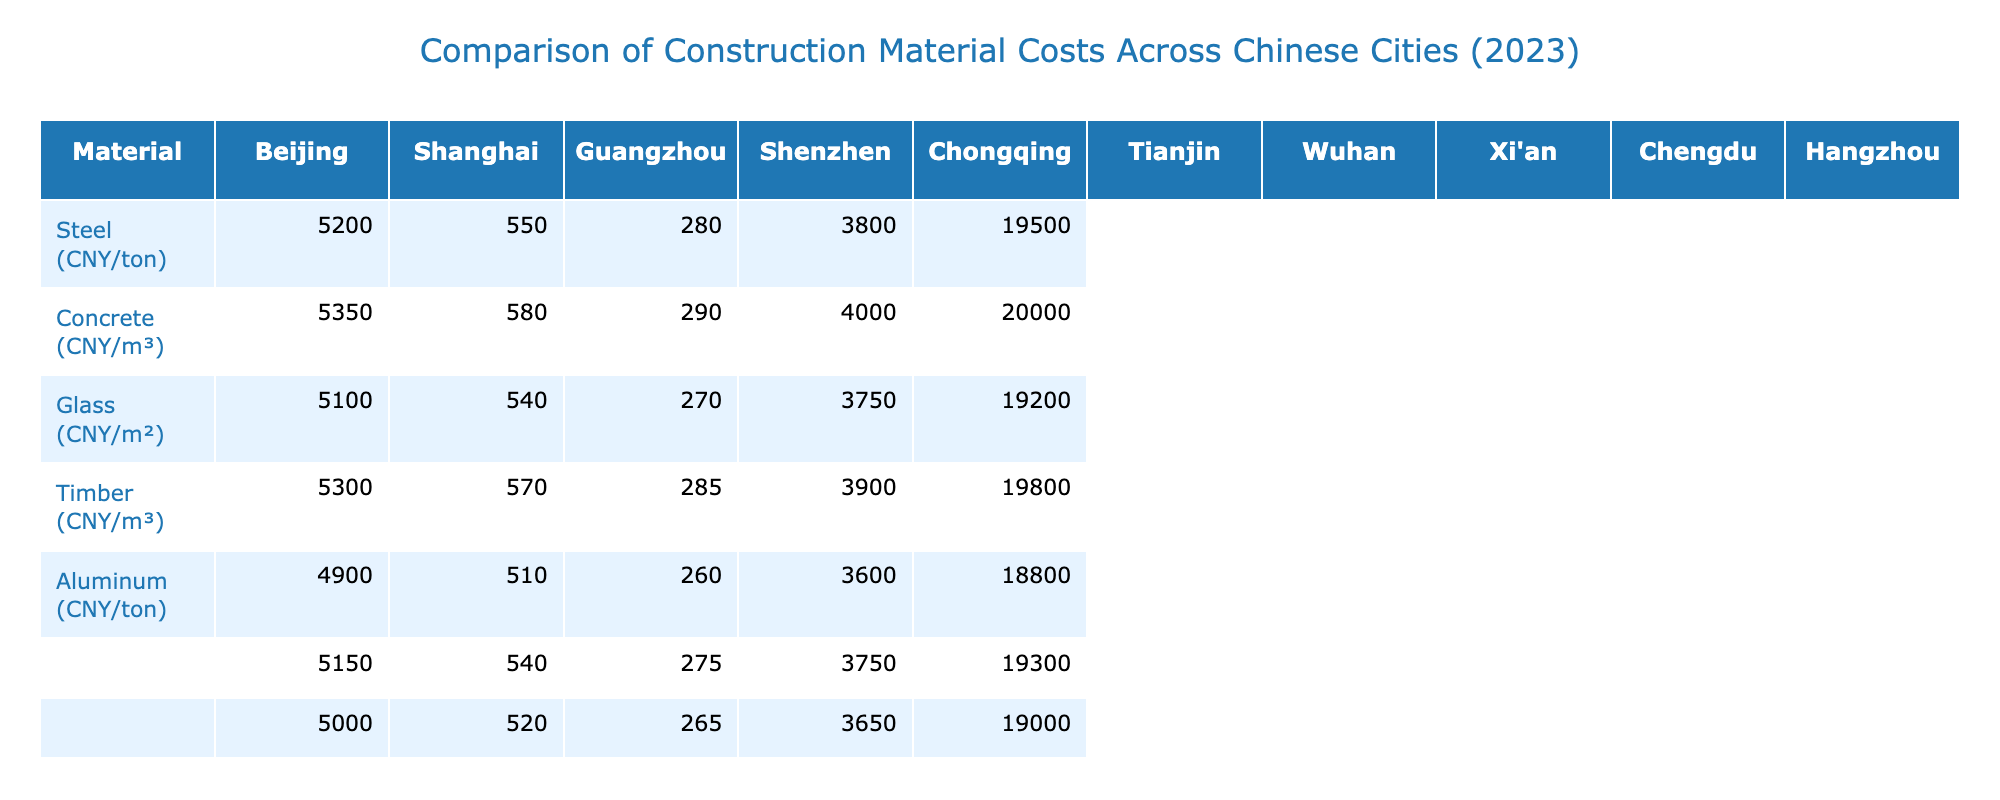What is the cost of steel in Shanghai? The table shows the cost of steel in Shanghai as 5350 CNY per ton.
Answer: 5350 CNY/ton Which city has the highest concrete cost? By comparing the concrete costs listed, Shanghai has the highest cost at 580 CNY per cubic meter.
Answer: Shanghai What is the difference in the cost of aluminum between Beijing and Guangzhou? The cost of aluminum in Beijing is 19500 CNY/ton and in Guangzhou it is 19200 CNY/ton. The difference is 19500 - 19200 = 300 CNY/ton.
Answer: 300 CNY/ton Which two cities have the same cost for timber? The table shows that both Tianjin and Guangzhou have a timber cost of 3750 CNY per cubic meter.
Answer: Tianjin and Guangzhou What's the average cost of glass across all listed cities? First, add all the glass costs: 280 + 290 + 270 + 285 + 260 + 275 + 265 + 260 + 270 + 280 = 2840. Then, divide by the number of cities (10): 2840 / 10 = 284.
Answer: 284 CNY/m² Is the cost of concrete in Wuhan higher than that in Chongqing? The cost of concrete in Wuhan is 520 CNY/m³, while in Chongqing it is 510 CNY/m³. Since 520 > 510, the statement is true.
Answer: Yes What is the total cost of steel and timber in Hangzhou? The cost of steel in Hangzhou is 5250 CNY/ton, and the cost of timber is 3850 CNY/m³. Adding them gives 5250 + 3850 = 9100 CNY.
Answer: 9100 CNY Which material is the cheapest in Guangzhou? Looking at the table, the cheapest material in Guangzhou is glass at 270 CNY/m².
Answer: Glass If we compare the aluminum costs in Shenzhen and Hangzhou, what is the cost difference? Aluminum costs in Shenzhen are 19800 CNY/ton and in Hangzhou are 19600 CNY/ton. The difference is 19800 - 19600 = 200 CNY/ton.
Answer: 200 CNY/ton Which city offers the lowest price for concrete? The lowest price for concrete is found in Chongqing at 510 CNY/m³.
Answer: Chongqing 